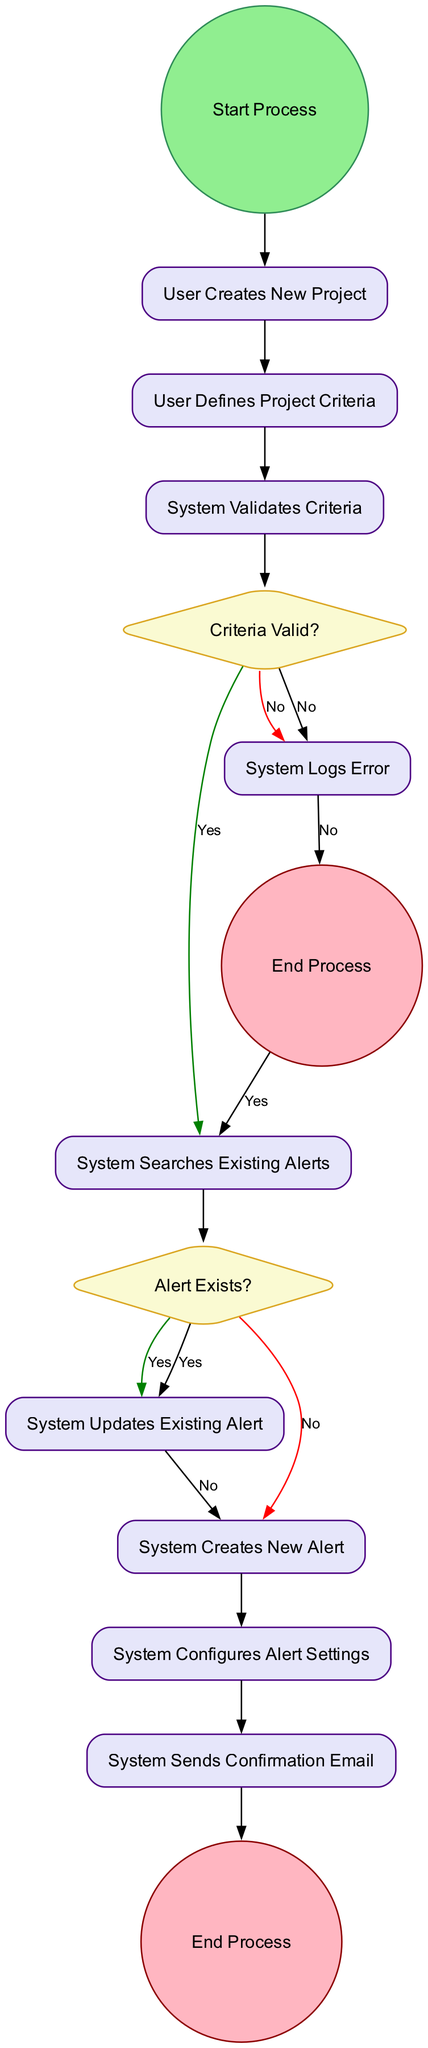What is the first action in the diagram? The first action in the diagram is "User Creates New Project." It is directly after the "Start Process" node, marking the beginning of the process.
Answer: User Creates New Project What happens if the project criteria are not valid? If the project criteria are not valid (the answer to the "Criteria Valid?" decision is "No"), the process leads to the "System Logs Error" action, followed by an "End Process" node.
Answer: System Logs Error How many decision points are present in the diagram? The diagram contains two decision points: "Criteria Valid?" and "Alert Exists?". Each of these decision points has branching paths based on yes or no outcomes.
Answer: 2 What action is taken when an alert already exists? When an alert already exists (the answer to the "Alert Exists?" decision is "Yes"), the next action taken is "System Updates Existing Alert." This follows from the decision branching off in the positive direction.
Answer: System Updates Existing Alert What is the last action performed in the process? The last action performed in the process is "System Sends Confirmation Email." This action takes place just before reaching the final "End Process" node.
Answer: System Sends Confirmation Email What are the outbound paths from the "Alert Exists?" decision? The "Alert Exists?" decision has two outbound paths: one leading to "System Updates Existing Alert" for the "Yes" outcome and another leading to "System Creates New Alert" for the "No" outcome.
Answer: System Updates Existing Alert, System Creates New Alert 